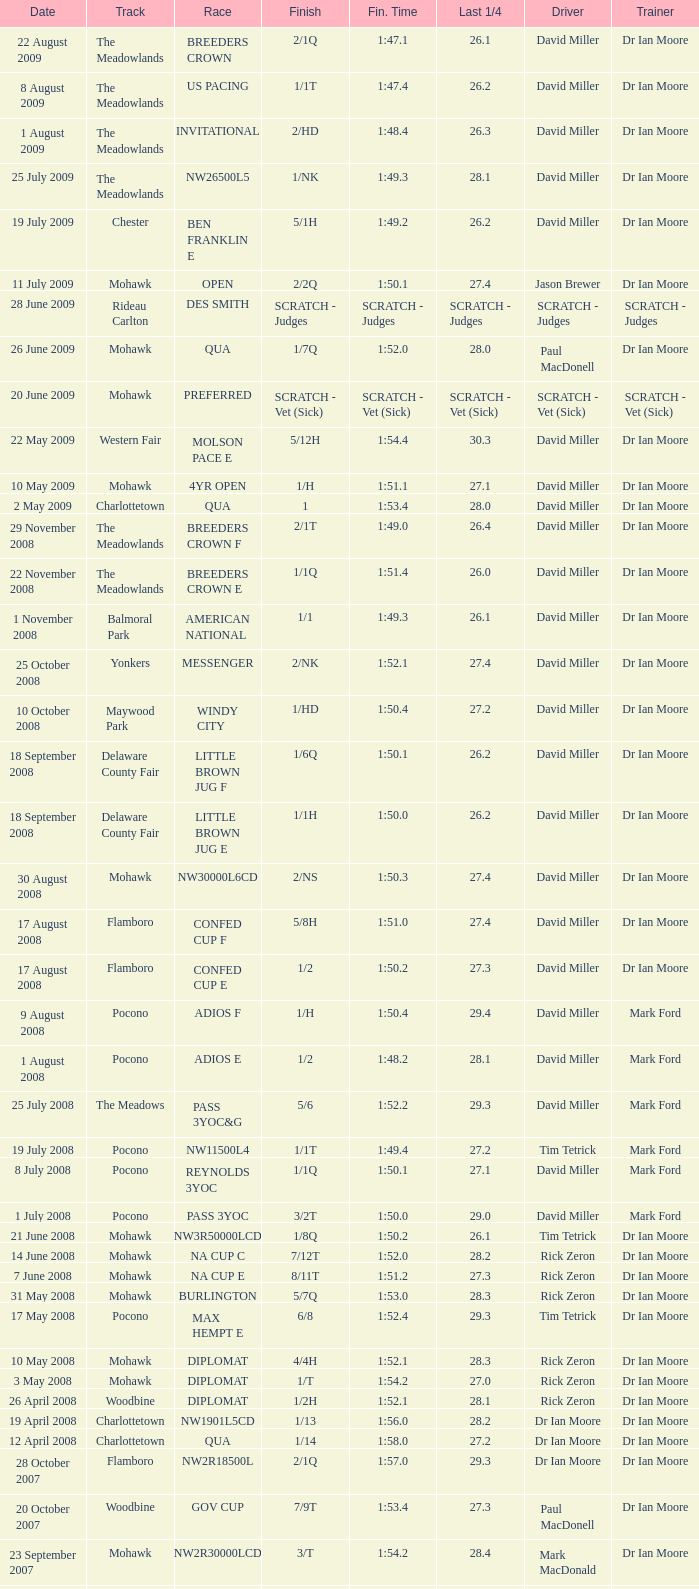What is the concluding time with a 2/1q finish on the meadowlands circuit? 1:47.1. Parse the table in full. {'header': ['Date', 'Track', 'Race', 'Finish', 'Fin. Time', 'Last 1/4', 'Driver', 'Trainer'], 'rows': [['22 August 2009', 'The Meadowlands', 'BREEDERS CROWN', '2/1Q', '1:47.1', '26.1', 'David Miller', 'Dr Ian Moore'], ['8 August 2009', 'The Meadowlands', 'US PACING', '1/1T', '1:47.4', '26.2', 'David Miller', 'Dr Ian Moore'], ['1 August 2009', 'The Meadowlands', 'INVITATIONAL', '2/HD', '1:48.4', '26.3', 'David Miller', 'Dr Ian Moore'], ['25 July 2009', 'The Meadowlands', 'NW26500L5', '1/NK', '1:49.3', '28.1', 'David Miller', 'Dr Ian Moore'], ['19 July 2009', 'Chester', 'BEN FRANKLIN E', '5/1H', '1:49.2', '26.2', 'David Miller', 'Dr Ian Moore'], ['11 July 2009', 'Mohawk', 'OPEN', '2/2Q', '1:50.1', '27.4', 'Jason Brewer', 'Dr Ian Moore'], ['28 June 2009', 'Rideau Carlton', 'DES SMITH', 'SCRATCH - Judges', 'SCRATCH - Judges', 'SCRATCH - Judges', 'SCRATCH - Judges', 'SCRATCH - Judges'], ['26 June 2009', 'Mohawk', 'QUA', '1/7Q', '1:52.0', '28.0', 'Paul MacDonell', 'Dr Ian Moore'], ['20 June 2009', 'Mohawk', 'PREFERRED', 'SCRATCH - Vet (Sick)', 'SCRATCH - Vet (Sick)', 'SCRATCH - Vet (Sick)', 'SCRATCH - Vet (Sick)', 'SCRATCH - Vet (Sick)'], ['22 May 2009', 'Western Fair', 'MOLSON PACE E', '5/12H', '1:54.4', '30.3', 'David Miller', 'Dr Ian Moore'], ['10 May 2009', 'Mohawk', '4YR OPEN', '1/H', '1:51.1', '27.1', 'David Miller', 'Dr Ian Moore'], ['2 May 2009', 'Charlottetown', 'QUA', '1', '1:53.4', '28.0', 'David Miller', 'Dr Ian Moore'], ['29 November 2008', 'The Meadowlands', 'BREEDERS CROWN F', '2/1T', '1:49.0', '26.4', 'David Miller', 'Dr Ian Moore'], ['22 November 2008', 'The Meadowlands', 'BREEDERS CROWN E', '1/1Q', '1:51.4', '26.0', 'David Miller', 'Dr Ian Moore'], ['1 November 2008', 'Balmoral Park', 'AMERICAN NATIONAL', '1/1', '1:49.3', '26.1', 'David Miller', 'Dr Ian Moore'], ['25 October 2008', 'Yonkers', 'MESSENGER', '2/NK', '1:52.1', '27.4', 'David Miller', 'Dr Ian Moore'], ['10 October 2008', 'Maywood Park', 'WINDY CITY', '1/HD', '1:50.4', '27.2', 'David Miller', 'Dr Ian Moore'], ['18 September 2008', 'Delaware County Fair', 'LITTLE BROWN JUG F', '1/6Q', '1:50.1', '26.2', 'David Miller', 'Dr Ian Moore'], ['18 September 2008', 'Delaware County Fair', 'LITTLE BROWN JUG E', '1/1H', '1:50.0', '26.2', 'David Miller', 'Dr Ian Moore'], ['30 August 2008', 'Mohawk', 'NW30000L6CD', '2/NS', '1:50.3', '27.4', 'David Miller', 'Dr Ian Moore'], ['17 August 2008', 'Flamboro', 'CONFED CUP F', '5/8H', '1:51.0', '27.4', 'David Miller', 'Dr Ian Moore'], ['17 August 2008', 'Flamboro', 'CONFED CUP E', '1/2', '1:50.2', '27.3', 'David Miller', 'Dr Ian Moore'], ['9 August 2008', 'Pocono', 'ADIOS F', '1/H', '1:50.4', '29.4', 'David Miller', 'Mark Ford'], ['1 August 2008', 'Pocono', 'ADIOS E', '1/2', '1:48.2', '28.1', 'David Miller', 'Mark Ford'], ['25 July 2008', 'The Meadows', 'PASS 3YOC&G', '5/6', '1:52.2', '29.3', 'David Miller', 'Mark Ford'], ['19 July 2008', 'Pocono', 'NW11500L4', '1/1T', '1:49.4', '27.2', 'Tim Tetrick', 'Mark Ford'], ['8 July 2008', 'Pocono', 'REYNOLDS 3YOC', '1/1Q', '1:50.1', '27.1', 'David Miller', 'Mark Ford'], ['1 July 2008', 'Pocono', 'PASS 3YOC', '3/2T', '1:50.0', '29.0', 'David Miller', 'Mark Ford'], ['21 June 2008', 'Mohawk', 'NW3R50000LCD', '1/8Q', '1:50.2', '26.1', 'Tim Tetrick', 'Dr Ian Moore'], ['14 June 2008', 'Mohawk', 'NA CUP C', '7/12T', '1:52.0', '28.2', 'Rick Zeron', 'Dr Ian Moore'], ['7 June 2008', 'Mohawk', 'NA CUP E', '8/11T', '1:51.2', '27.3', 'Rick Zeron', 'Dr Ian Moore'], ['31 May 2008', 'Mohawk', 'BURLINGTON', '5/7Q', '1:53.0', '28.3', 'Rick Zeron', 'Dr Ian Moore'], ['17 May 2008', 'Pocono', 'MAX HEMPT E', '6/8', '1:52.4', '29.3', 'Tim Tetrick', 'Dr Ian Moore'], ['10 May 2008', 'Mohawk', 'DIPLOMAT', '4/4H', '1:52.1', '28.3', 'Rick Zeron', 'Dr Ian Moore'], ['3 May 2008', 'Mohawk', 'DIPLOMAT', '1/T', '1:54.2', '27.0', 'Rick Zeron', 'Dr Ian Moore'], ['26 April 2008', 'Woodbine', 'DIPLOMAT', '1/2H', '1:52.1', '28.1', 'Rick Zeron', 'Dr Ian Moore'], ['19 April 2008', 'Charlottetown', 'NW1901L5CD', '1/13', '1:56.0', '28.2', 'Dr Ian Moore', 'Dr Ian Moore'], ['12 April 2008', 'Charlottetown', 'QUA', '1/14', '1:58.0', '27.2', 'Dr Ian Moore', 'Dr Ian Moore'], ['28 October 2007', 'Flamboro', 'NW2R18500L', '2/1Q', '1:57.0', '29.3', 'Dr Ian Moore', 'Dr Ian Moore'], ['20 October 2007', 'Woodbine', 'GOV CUP', '7/9T', '1:53.4', '27.3', 'Paul MacDonell', 'Dr Ian Moore'], ['23 September 2007', 'Mohawk', 'NW2R30000LCD', '3/T', '1:54.2', '28.4', 'Mark MacDonald', 'Dr Ian Moore'], ['15 September 2007', 'Mohawk', 'NASAGAWEYA', '8/12T', '1:55.2', '30.3', 'Mark MacDonald', 'Dr Ian Moore'], ['1 September 2007', 'Mohawk', 'METRO F', '6/9T', '1:51.3', '28.2', 'Mark MacDonald', 'Dr Ian Moore'], ['25 August 2007', 'Mohawk', 'METRO E', '3/4', '1:53.0', '28.1', 'Mark MacDonald', 'Dr Ian Moore'], ['19 August 2007', 'Mohawk', 'NW2R22000LCD', '3/1', '1:53.1', '27.2', 'Paul MacDonell', 'Dr Ian Moore'], ['6 August 2007', 'Mohawk', 'DREAM MAKER', '4/2Q', '1:54.1', '28.1', 'Paul MacDonell', 'Dr Ian Moore'], ['30 July 2007', 'Mohawk', 'DREAM MAKER', '2/1T', '1:53.4', '30.0', 'Dr Ian Moore', 'Dr Ian Moore'], ['23 July 2007', 'Mohawk', 'DREAM MAKER', '2/Q', '1:54.0', '27.4', 'Paul MacDonell', 'Dr Ian Moore'], ['15 July 2007', 'Mohawk', '2YR-C-COND', '1/H', '1:57.2', '27.3', 'Dr Ian Moore', 'Dr Ian Moore'], ['30 June 2007', 'Charlottetown', 'NW2RLFTCD', '1/4H', '1:58.0', '28.1', 'Dr Ian Moore', 'Dr Ian Moore'], ['21 June 2007', 'Charlottetown', 'NW1RLFT', '1/4H', '2:02.3', '29.4', 'Dr Ian Moore', 'Dr Ian Moore'], ['14 June 2007', 'Charlottetown', 'QUA', '1/5H', '2:03.1', '29.2', 'Dr Ian Moore', 'Dr Ian Moore']]} 